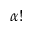Convert formula to latex. <formula><loc_0><loc_0><loc_500><loc_500>\alpha !</formula> 